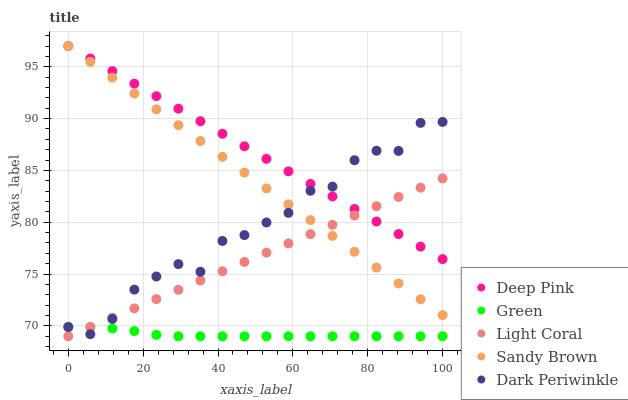Does Green have the minimum area under the curve?
Answer yes or no. Yes. Does Deep Pink have the maximum area under the curve?
Answer yes or no. Yes. Does Sandy Brown have the minimum area under the curve?
Answer yes or no. No. Does Sandy Brown have the maximum area under the curve?
Answer yes or no. No. Is Light Coral the smoothest?
Answer yes or no. Yes. Is Dark Periwinkle the roughest?
Answer yes or no. Yes. Is Sandy Brown the smoothest?
Answer yes or no. No. Is Sandy Brown the roughest?
Answer yes or no. No. Does Light Coral have the lowest value?
Answer yes or no. Yes. Does Sandy Brown have the lowest value?
Answer yes or no. No. Does Deep Pink have the highest value?
Answer yes or no. Yes. Does Green have the highest value?
Answer yes or no. No. Is Green less than Sandy Brown?
Answer yes or no. Yes. Is Deep Pink greater than Green?
Answer yes or no. Yes. Does Deep Pink intersect Dark Periwinkle?
Answer yes or no. Yes. Is Deep Pink less than Dark Periwinkle?
Answer yes or no. No. Is Deep Pink greater than Dark Periwinkle?
Answer yes or no. No. Does Green intersect Sandy Brown?
Answer yes or no. No. 